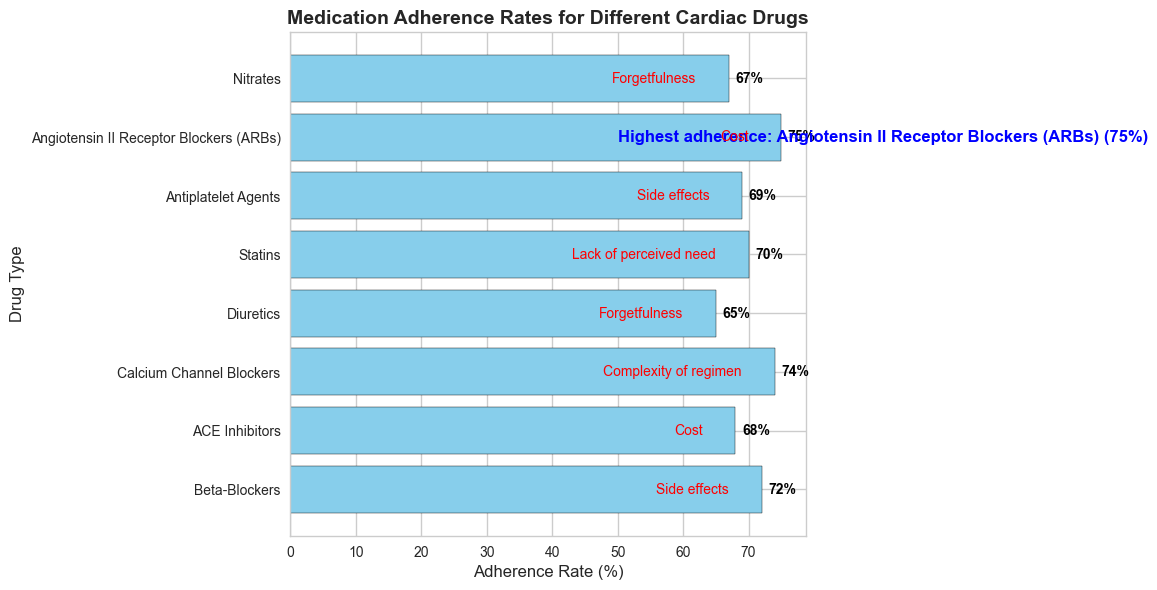Which cardiac drug has the highest medication adherence rate? By looking at the annotation and the bar lengths, Angiotensin II Receptor Blockers (ARBs) have an adherence rate of 75%, the highest in the chart.
Answer: Angiotensin II Receptor Blockers (ARBs) Which drug type has the lowest adherence rate and what is the key reason for non-adherence? By observing the shortest bar, Diuretics have the lowest adherence rate at 65%. The key reason for non-adherence, indicated by the red text, is "Forgetfulness".
Answer: Diuretics, Forgetfulness How much greater is the adherence rate for Angiotensin II Receptor Blockers (ARBs) compared to Diuretics? The adherence rate for ARBs is 75% and for Diuretics is 65%. The difference is 75% - 65% = 10%.
Answer: 10% What are the key reasons for non-adherence for Beta-Blockers and Antiplatelet Agents, and are they the same? The red text next to these bars shows the reasons for non-adherence. Both Beta-Blockers and Antiplatelet Agents have "Side effects" listed as the key reason for non-adherence.
Answer: Side effects, Yes Which drugs have adherence rates above 70%? By locating bars with adherence rates above 70%, the drugs are Beta-Blockers (72%), Calcium Channel Blockers (74%), and Angiotensin II Receptor Blockers (ARBs) (75%).
Answer: Beta-Blockers, Calcium Channel Blockers, Angiotensin II Receptor Blockers (ARBs) What is the average adherence rate of all the drugs? Add up the adherence rates of all the drugs and divide by the number of drugs. (72 + 68 + 74 + 65 + 70 + 69 + 75 + 67) / 8 = 560 / 8 = 70%
Answer: 70% How does the adherence rate for Statins compare to the rate for ACE Inhibitors? From the bar lengths, Statins have an adherence rate of 70% and ACE Inhibitors 68%. Statins have a higher adherence rate by 2%.
Answer: Statins higher by 2% Which visual feature is used to highlight the drug with the highest adherence rate? The annotation near the bar for Angiotensin II Receptor Blockers (ARBs) and the blue text indicate the highest adherence rate.
Answer: Blue text annotation What is the key reason for non-adherence for the drug with the highest adherence rate? The red text next to the bar for Angiotensin II Receptor Blockers (ARBs) shows "Cost" as the key reason for non-adherence.
Answer: Cost 